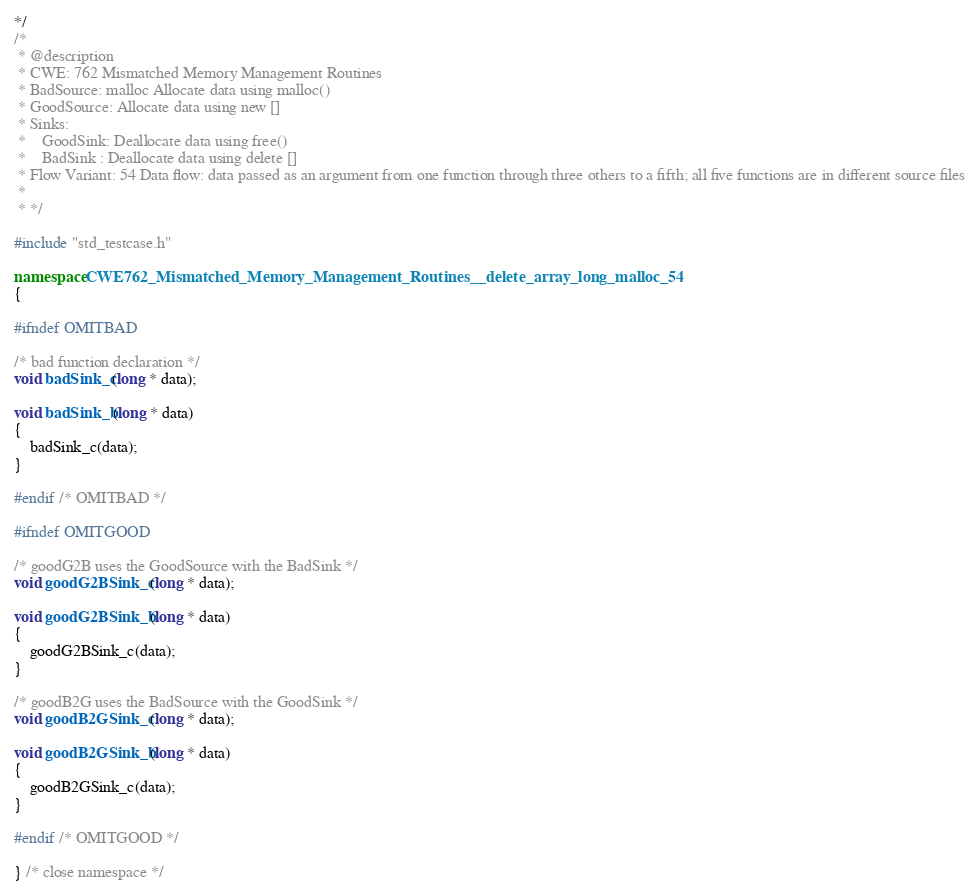Convert code to text. <code><loc_0><loc_0><loc_500><loc_500><_C++_>*/
/*
 * @description
 * CWE: 762 Mismatched Memory Management Routines
 * BadSource: malloc Allocate data using malloc()
 * GoodSource: Allocate data using new []
 * Sinks:
 *    GoodSink: Deallocate data using free()
 *    BadSink : Deallocate data using delete []
 * Flow Variant: 54 Data flow: data passed as an argument from one function through three others to a fifth; all five functions are in different source files
 *
 * */

#include "std_testcase.h"

namespace CWE762_Mismatched_Memory_Management_Routines__delete_array_long_malloc_54
{

#ifndef OMITBAD

/* bad function declaration */
void badSink_c(long * data);

void badSink_b(long * data)
{
    badSink_c(data);
}

#endif /* OMITBAD */

#ifndef OMITGOOD

/* goodG2B uses the GoodSource with the BadSink */
void goodG2BSink_c(long * data);

void goodG2BSink_b(long * data)
{
    goodG2BSink_c(data);
}

/* goodB2G uses the BadSource with the GoodSink */
void goodB2GSink_c(long * data);

void goodB2GSink_b(long * data)
{
    goodB2GSink_c(data);
}

#endif /* OMITGOOD */

} /* close namespace */
</code> 